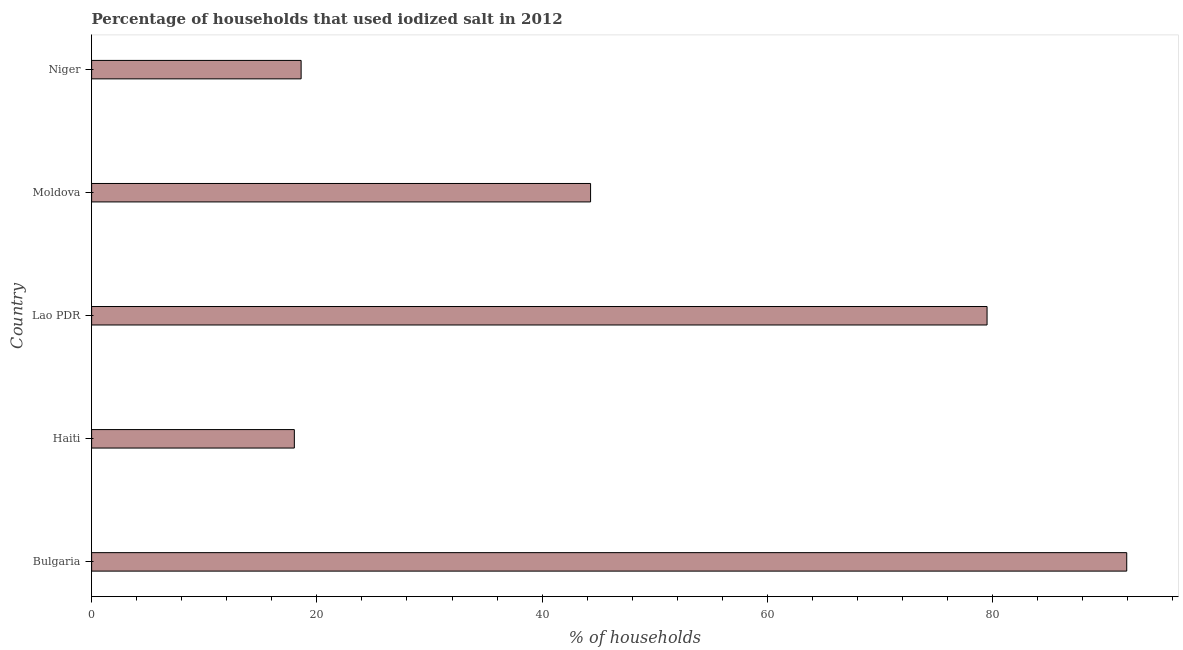What is the title of the graph?
Your answer should be very brief. Percentage of households that used iodized salt in 2012. What is the label or title of the X-axis?
Offer a terse response. % of households. What is the percentage of households where iodized salt is consumed in Moldova?
Your answer should be compact. 44.3. Across all countries, what is the maximum percentage of households where iodized salt is consumed?
Give a very brief answer. 91.9. Across all countries, what is the minimum percentage of households where iodized salt is consumed?
Offer a very short reply. 18. In which country was the percentage of households where iodized salt is consumed minimum?
Ensure brevity in your answer.  Haiti. What is the sum of the percentage of households where iodized salt is consumed?
Give a very brief answer. 252.3. What is the difference between the percentage of households where iodized salt is consumed in Bulgaria and Moldova?
Give a very brief answer. 47.6. What is the average percentage of households where iodized salt is consumed per country?
Your answer should be compact. 50.46. What is the median percentage of households where iodized salt is consumed?
Provide a short and direct response. 44.3. In how many countries, is the percentage of households where iodized salt is consumed greater than 80 %?
Provide a succinct answer. 1. Is the percentage of households where iodized salt is consumed in Bulgaria less than that in Lao PDR?
Provide a short and direct response. No. What is the difference between the highest and the lowest percentage of households where iodized salt is consumed?
Provide a succinct answer. 73.9. How many bars are there?
Your response must be concise. 5. Are all the bars in the graph horizontal?
Keep it short and to the point. Yes. What is the % of households of Bulgaria?
Make the answer very short. 91.9. What is the % of households of Lao PDR?
Your response must be concise. 79.5. What is the % of households of Moldova?
Ensure brevity in your answer.  44.3. What is the % of households of Niger?
Offer a terse response. 18.6. What is the difference between the % of households in Bulgaria and Haiti?
Provide a succinct answer. 73.9. What is the difference between the % of households in Bulgaria and Lao PDR?
Offer a very short reply. 12.4. What is the difference between the % of households in Bulgaria and Moldova?
Offer a very short reply. 47.6. What is the difference between the % of households in Bulgaria and Niger?
Provide a short and direct response. 73.3. What is the difference between the % of households in Haiti and Lao PDR?
Make the answer very short. -61.5. What is the difference between the % of households in Haiti and Moldova?
Keep it short and to the point. -26.3. What is the difference between the % of households in Haiti and Niger?
Ensure brevity in your answer.  -0.6. What is the difference between the % of households in Lao PDR and Moldova?
Your response must be concise. 35.2. What is the difference between the % of households in Lao PDR and Niger?
Provide a short and direct response. 60.9. What is the difference between the % of households in Moldova and Niger?
Ensure brevity in your answer.  25.7. What is the ratio of the % of households in Bulgaria to that in Haiti?
Provide a succinct answer. 5.11. What is the ratio of the % of households in Bulgaria to that in Lao PDR?
Offer a very short reply. 1.16. What is the ratio of the % of households in Bulgaria to that in Moldova?
Keep it short and to the point. 2.07. What is the ratio of the % of households in Bulgaria to that in Niger?
Your response must be concise. 4.94. What is the ratio of the % of households in Haiti to that in Lao PDR?
Your response must be concise. 0.23. What is the ratio of the % of households in Haiti to that in Moldova?
Your answer should be compact. 0.41. What is the ratio of the % of households in Haiti to that in Niger?
Provide a succinct answer. 0.97. What is the ratio of the % of households in Lao PDR to that in Moldova?
Your answer should be very brief. 1.79. What is the ratio of the % of households in Lao PDR to that in Niger?
Give a very brief answer. 4.27. What is the ratio of the % of households in Moldova to that in Niger?
Keep it short and to the point. 2.38. 